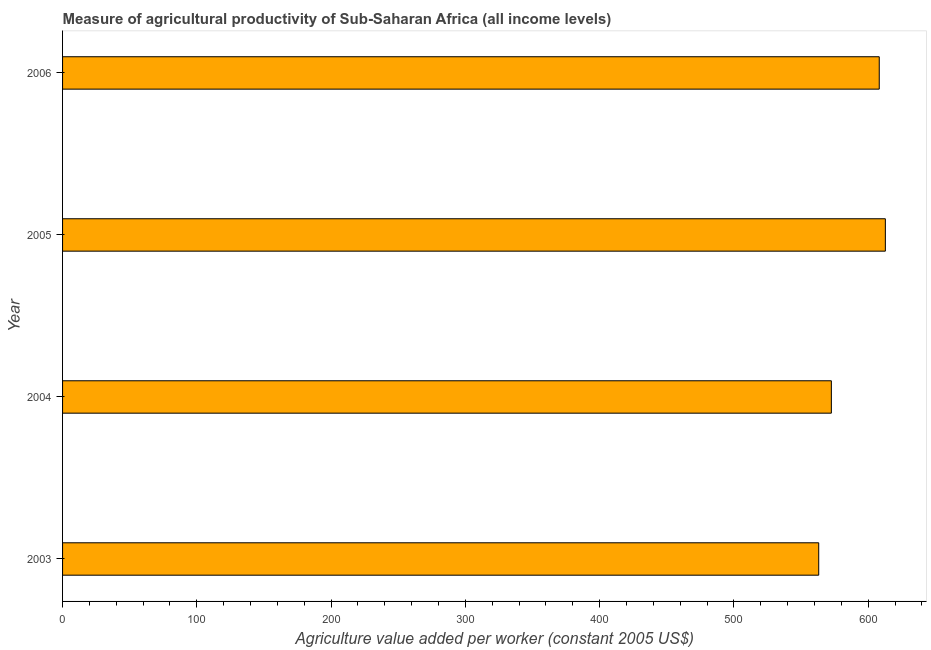Does the graph contain grids?
Offer a very short reply. No. What is the title of the graph?
Your answer should be very brief. Measure of agricultural productivity of Sub-Saharan Africa (all income levels). What is the label or title of the X-axis?
Offer a very short reply. Agriculture value added per worker (constant 2005 US$). What is the label or title of the Y-axis?
Your answer should be compact. Year. What is the agriculture value added per worker in 2006?
Offer a very short reply. 608.24. Across all years, what is the maximum agriculture value added per worker?
Give a very brief answer. 612.78. Across all years, what is the minimum agriculture value added per worker?
Provide a succinct answer. 563.16. What is the sum of the agriculture value added per worker?
Offer a very short reply. 2356.74. What is the difference between the agriculture value added per worker in 2003 and 2005?
Offer a terse response. -49.63. What is the average agriculture value added per worker per year?
Keep it short and to the point. 589.19. What is the median agriculture value added per worker?
Give a very brief answer. 590.4. In how many years, is the agriculture value added per worker greater than 60 US$?
Keep it short and to the point. 4. Is the difference between the agriculture value added per worker in 2003 and 2004 greater than the difference between any two years?
Give a very brief answer. No. What is the difference between the highest and the second highest agriculture value added per worker?
Provide a short and direct response. 4.54. What is the difference between the highest and the lowest agriculture value added per worker?
Your answer should be very brief. 49.63. How many years are there in the graph?
Ensure brevity in your answer.  4. What is the difference between two consecutive major ticks on the X-axis?
Offer a very short reply. 100. What is the Agriculture value added per worker (constant 2005 US$) of 2003?
Give a very brief answer. 563.16. What is the Agriculture value added per worker (constant 2005 US$) in 2004?
Your answer should be very brief. 572.57. What is the Agriculture value added per worker (constant 2005 US$) of 2005?
Ensure brevity in your answer.  612.78. What is the Agriculture value added per worker (constant 2005 US$) of 2006?
Make the answer very short. 608.24. What is the difference between the Agriculture value added per worker (constant 2005 US$) in 2003 and 2004?
Make the answer very short. -9.41. What is the difference between the Agriculture value added per worker (constant 2005 US$) in 2003 and 2005?
Give a very brief answer. -49.63. What is the difference between the Agriculture value added per worker (constant 2005 US$) in 2003 and 2006?
Ensure brevity in your answer.  -45.08. What is the difference between the Agriculture value added per worker (constant 2005 US$) in 2004 and 2005?
Give a very brief answer. -40.21. What is the difference between the Agriculture value added per worker (constant 2005 US$) in 2004 and 2006?
Offer a very short reply. -35.67. What is the difference between the Agriculture value added per worker (constant 2005 US$) in 2005 and 2006?
Your response must be concise. 4.55. What is the ratio of the Agriculture value added per worker (constant 2005 US$) in 2003 to that in 2005?
Provide a short and direct response. 0.92. What is the ratio of the Agriculture value added per worker (constant 2005 US$) in 2003 to that in 2006?
Offer a terse response. 0.93. What is the ratio of the Agriculture value added per worker (constant 2005 US$) in 2004 to that in 2005?
Make the answer very short. 0.93. What is the ratio of the Agriculture value added per worker (constant 2005 US$) in 2004 to that in 2006?
Offer a very short reply. 0.94. 